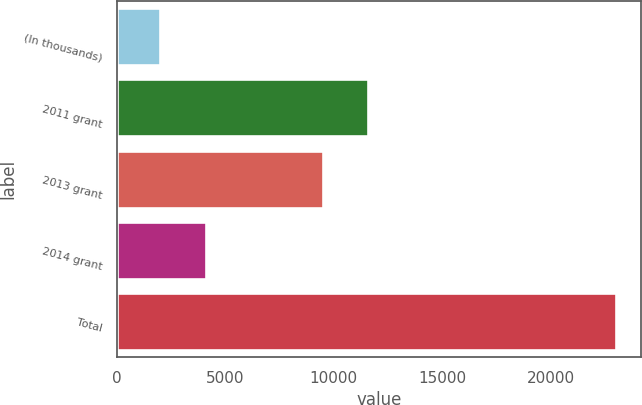<chart> <loc_0><loc_0><loc_500><loc_500><bar_chart><fcel>(In thousands)<fcel>2011 grant<fcel>2013 grant<fcel>2014 grant<fcel>Total<nl><fcel>2014<fcel>11592.7<fcel>9493<fcel>4113.7<fcel>23011<nl></chart> 